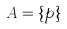Convert formula to latex. <formula><loc_0><loc_0><loc_500><loc_500>A = \{ p \}</formula> 